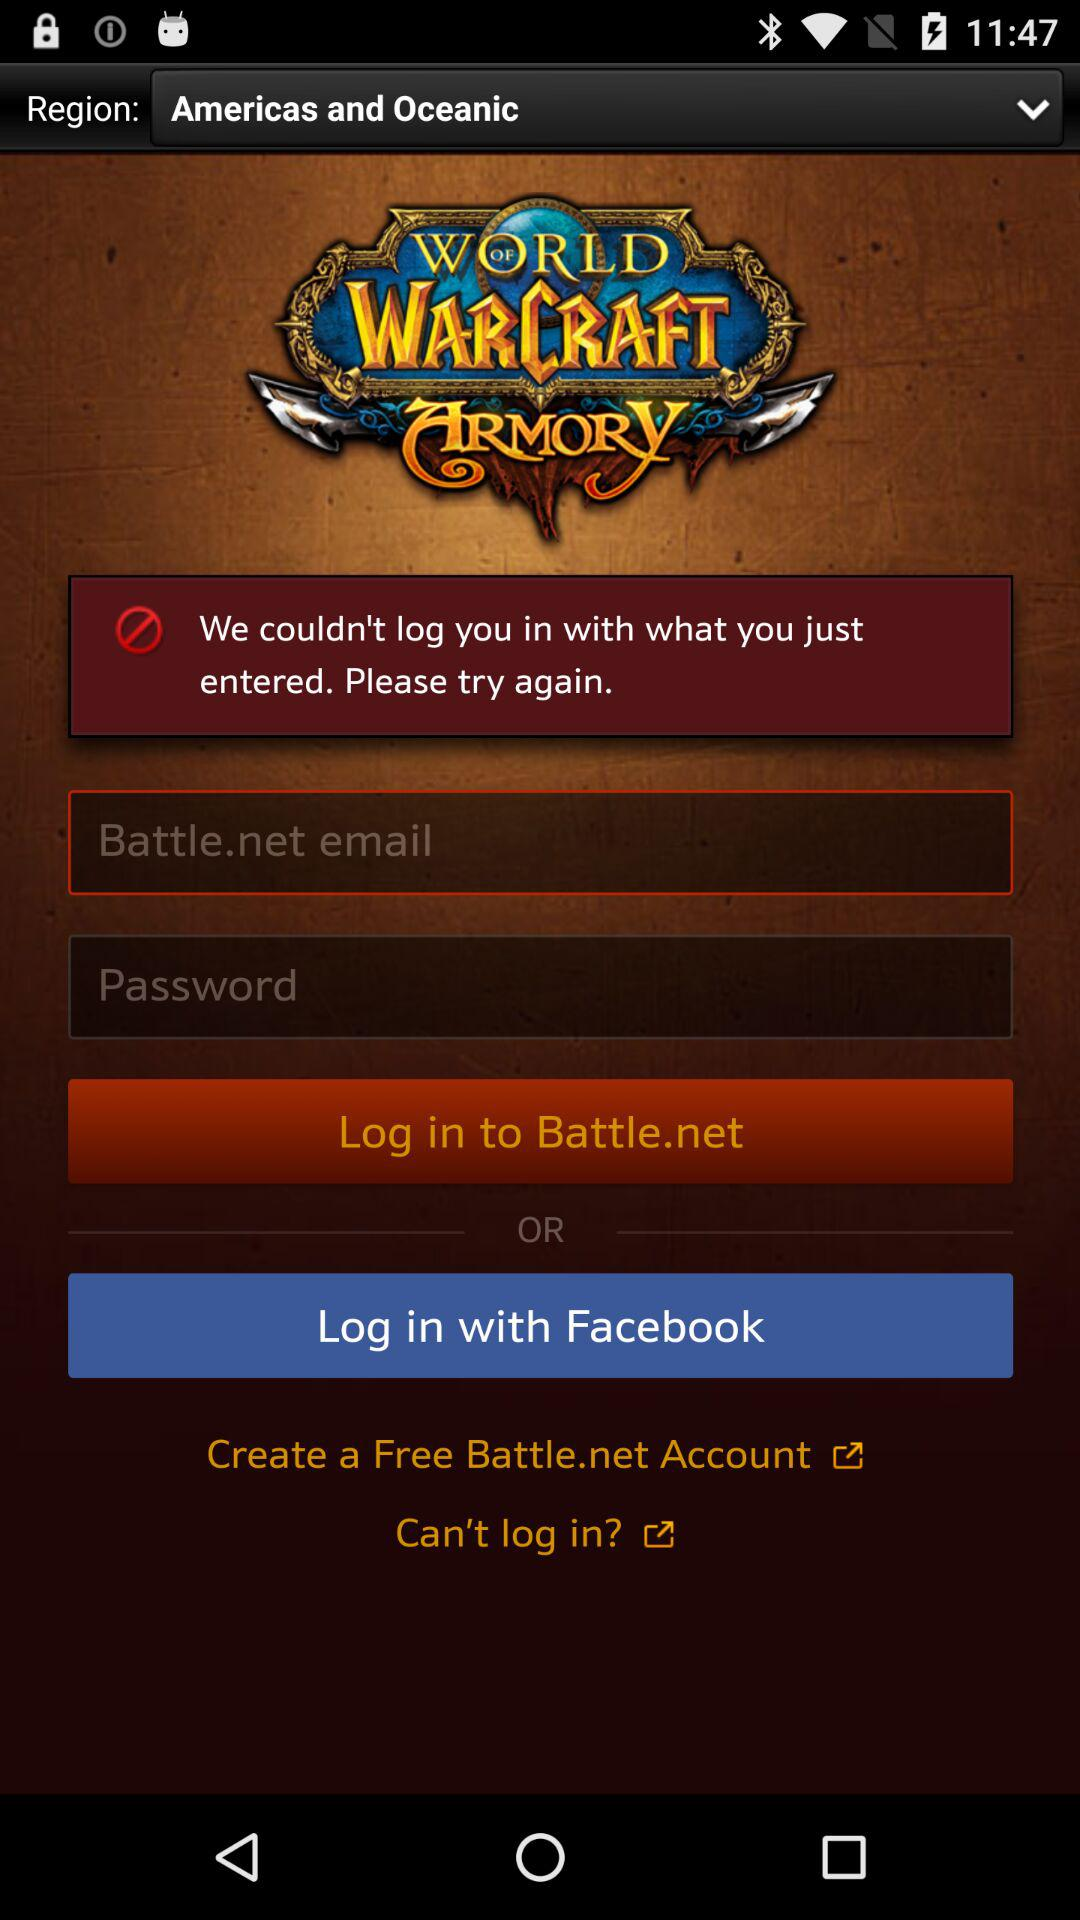How many text input fields are there on this screen?
Answer the question using a single word or phrase. 2 